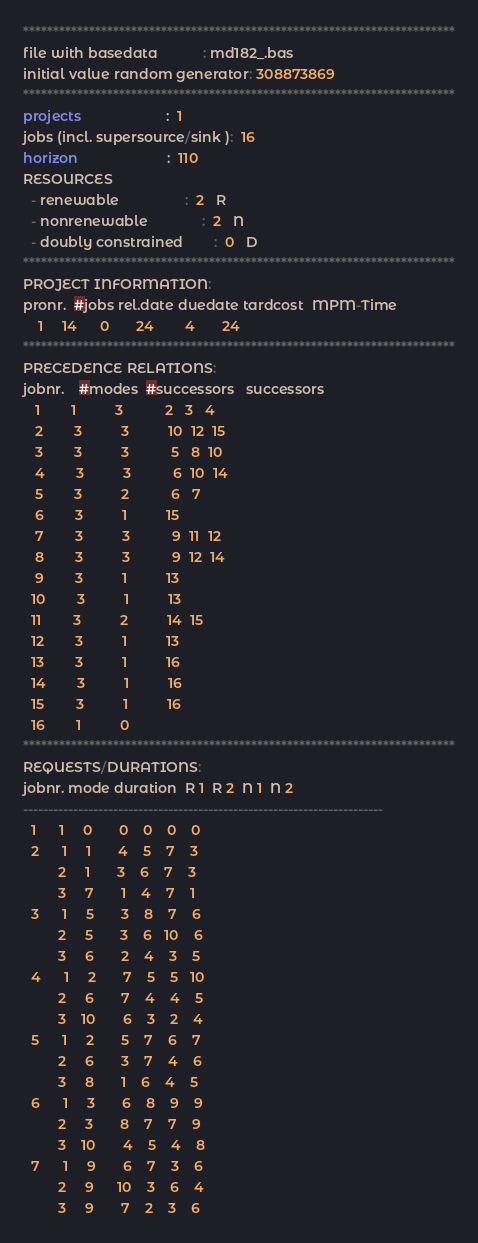<code> <loc_0><loc_0><loc_500><loc_500><_ObjectiveC_>************************************************************************
file with basedata            : md182_.bas
initial value random generator: 308873869
************************************************************************
projects                      :  1
jobs (incl. supersource/sink ):  16
horizon                       :  110
RESOURCES
  - renewable                 :  2   R
  - nonrenewable              :  2   N
  - doubly constrained        :  0   D
************************************************************************
PROJECT INFORMATION:
pronr.  #jobs rel.date duedate tardcost  MPM-Time
    1     14      0       24        4       24
************************************************************************
PRECEDENCE RELATIONS:
jobnr.    #modes  #successors   successors
   1        1          3           2   3   4
   2        3          3          10  12  15
   3        3          3           5   8  10
   4        3          3           6  10  14
   5        3          2           6   7
   6        3          1          15
   7        3          3           9  11  12
   8        3          3           9  12  14
   9        3          1          13
  10        3          1          13
  11        3          2          14  15
  12        3          1          13
  13        3          1          16
  14        3          1          16
  15        3          1          16
  16        1          0        
************************************************************************
REQUESTS/DURATIONS:
jobnr. mode duration  R 1  R 2  N 1  N 2
------------------------------------------------------------------------
  1      1     0       0    0    0    0
  2      1     1       4    5    7    3
         2     1       3    6    7    3
         3     7       1    4    7    1
  3      1     5       3    8    7    6
         2     5       3    6   10    6
         3     6       2    4    3    5
  4      1     2       7    5    5   10
         2     6       7    4    4    5
         3    10       6    3    2    4
  5      1     2       5    7    6    7
         2     6       3    7    4    6
         3     8       1    6    4    5
  6      1     3       6    8    9    9
         2     3       8    7    7    9
         3    10       4    5    4    8
  7      1     9       6    7    3    6
         2     9      10    3    6    4
         3     9       7    2    3    6</code> 